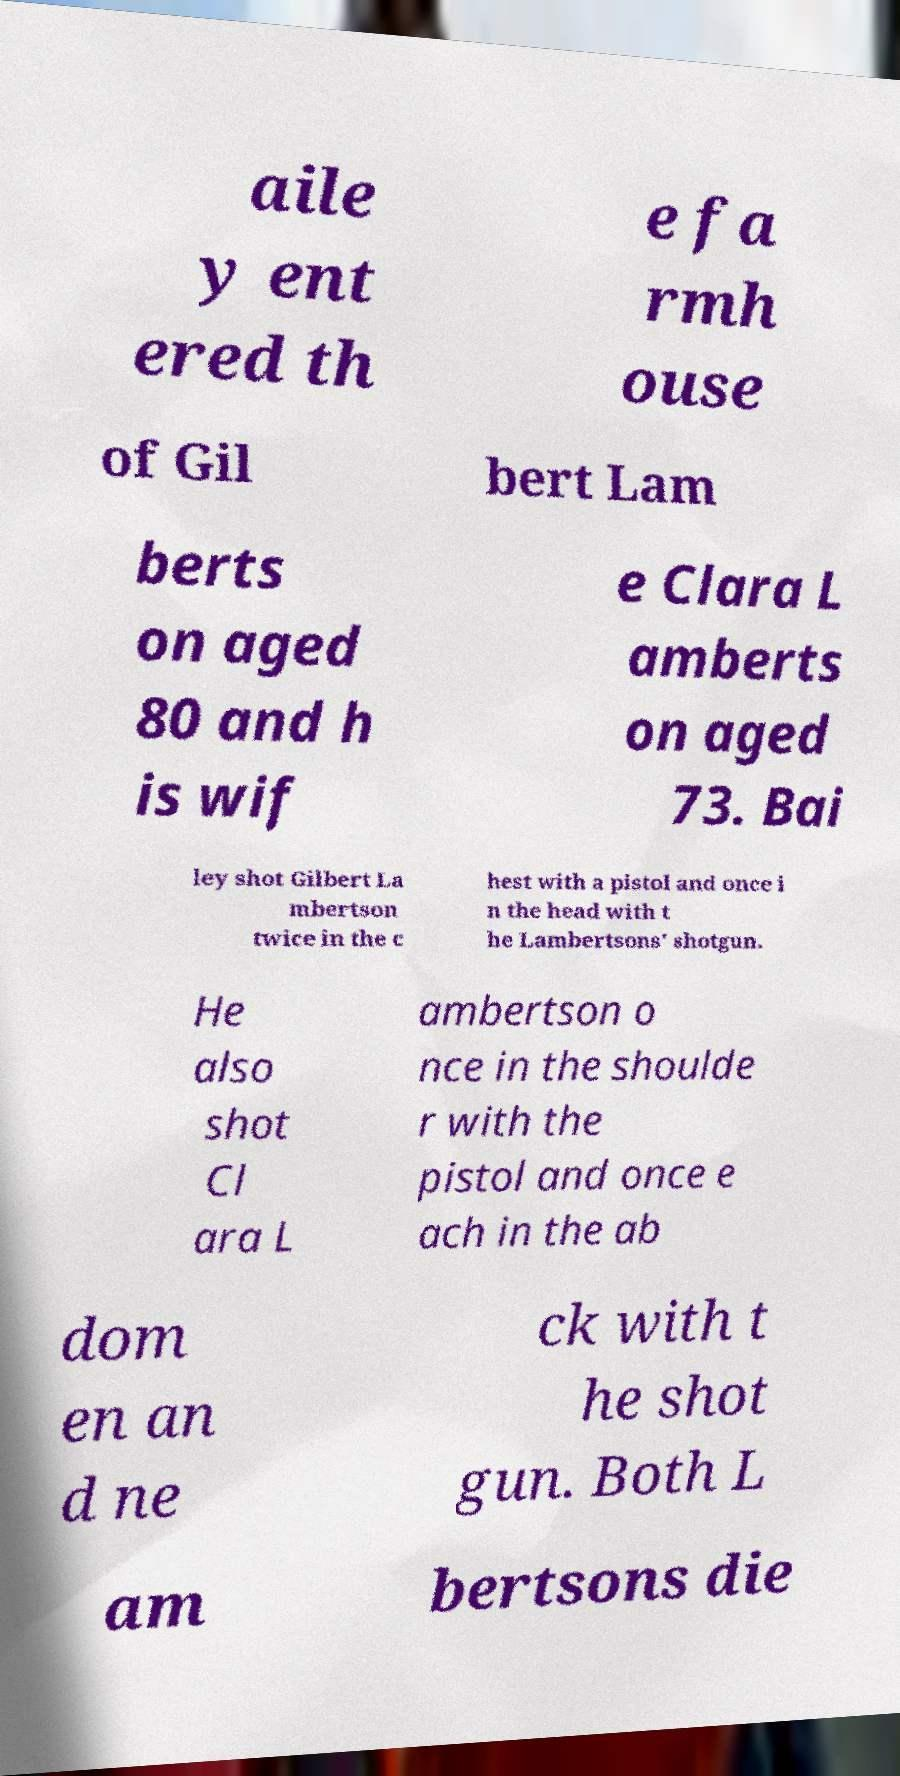Could you assist in decoding the text presented in this image and type it out clearly? aile y ent ered th e fa rmh ouse of Gil bert Lam berts on aged 80 and h is wif e Clara L amberts on aged 73. Bai ley shot Gilbert La mbertson twice in the c hest with a pistol and once i n the head with t he Lambertsons' shotgun. He also shot Cl ara L ambertson o nce in the shoulde r with the pistol and once e ach in the ab dom en an d ne ck with t he shot gun. Both L am bertsons die 